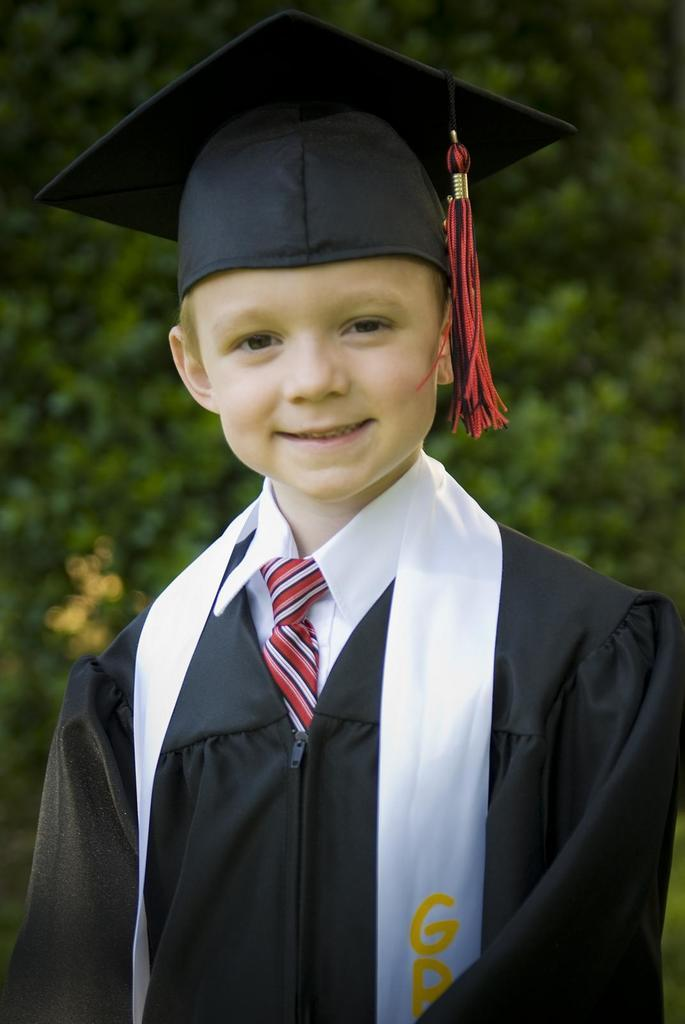What is the main subject in the image? There is a person standing in the image. Can you describe the background of the image? The background of the image is blurred. Is there a pest in the image that has received approval from the person standing? There is no pest or indication of approval in the image; it only features a person standing in a blurred background. Can you spot a squirrel in the image? There is no squirrel present in the image. 